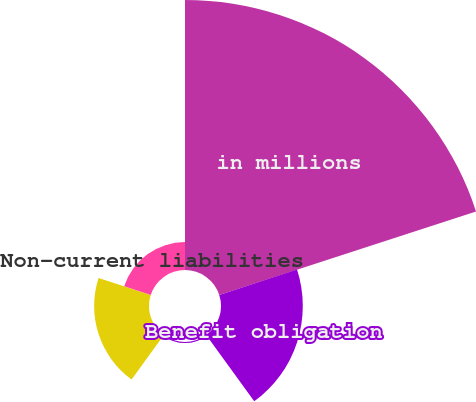Convert chart to OTSL. <chart><loc_0><loc_0><loc_500><loc_500><pie_chart><fcel>in millions<fcel>Benefit obligation<fcel>Fair value of plan assets<fcel>Funded status<fcel>Non-current liabilities<nl><fcel>61.96%<fcel>18.77%<fcel>0.25%<fcel>12.59%<fcel>6.42%<nl></chart> 